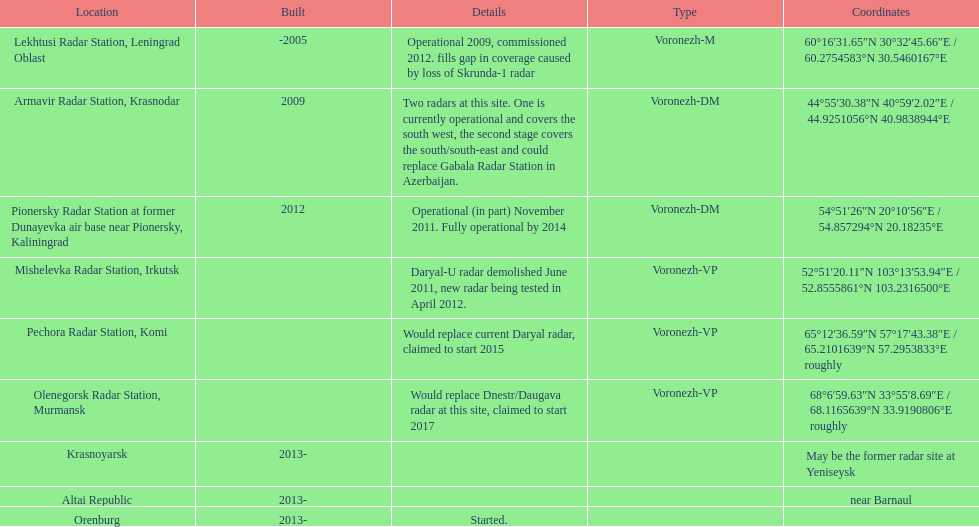What year built is at the top? -2005. 